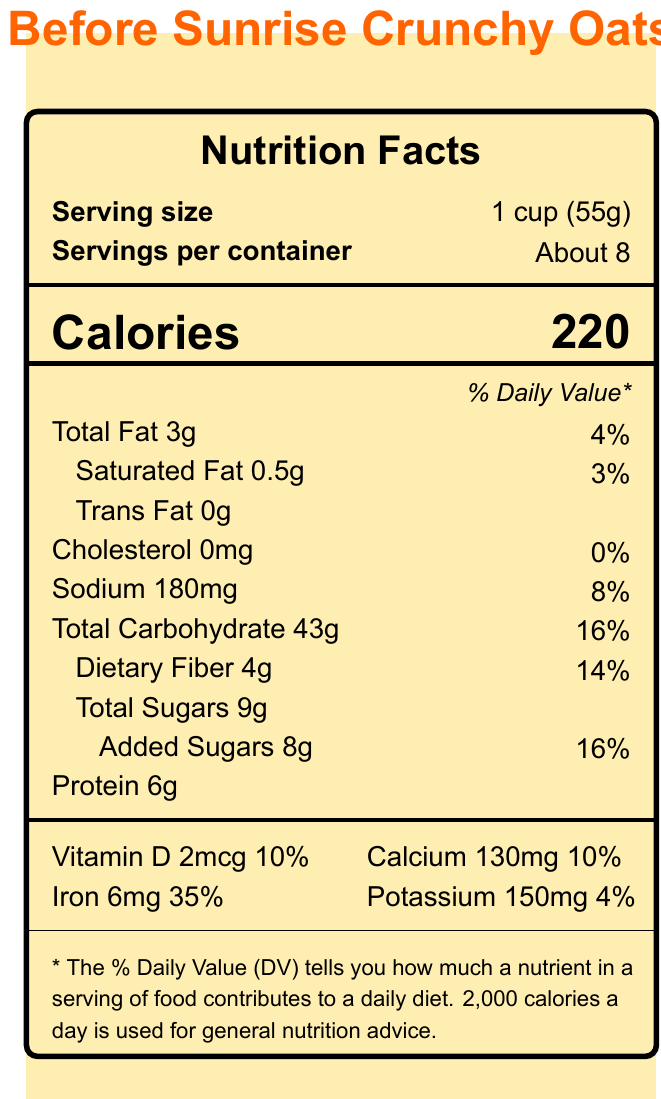what is the serving size? The serving size is clearly labeled as "1 cup (55g)" near the top of the Nutrition Facts section.
Answer: 1 cup (55g) how many calories are in one serving? The document lists "Calories" as 220 right beneath the serving size information.
Answer: 220 what is the percentage of Daily Value for Total Fat? The percentage of Daily Value for Total Fat is listed as 4% next to the amount of 3g.
Answer: 4% what is the amount of Dietary Fiber per serving? The amount of Dietary Fiber is listed as 4g.
Answer: 4g what vitamins and minerals are included in this cereal? The vitamins and minerals are listed towards the bottom of the Nutrition Facts as Vitamin D, Calcium, Iron, and Potassium.
Answer: Vitamin D, Calcium, Iron, Potassium which ingredient is listed first? A. Sugar B. Whole grain oats C. Corn syrup Whole grain oats is the first ingredient listed.
Answer: B what is the amount of sodium in the cereal? A. 180mg B. 150mg C. 130mg D. 0mg The amount of sodium is listed as 180mg.
Answer: A Is this cereal high in iron? (Yes/No) The Daily Value percentage for iron is 35%, which is relatively high.
Answer: Yes summarize the main information found in the document. The document showcases comprehensive nutritional information of the cereal "Before Sunrise Crunchy Oats" such as calorie content and nutrient percentages. It further includes ingredient and allergen details, fun facts about the "Before" trilogy, and a movie quote.
Answer: The document provides Nutrition Facts for "Before Sunrise Crunchy Oats" cereal, including serving size, calories, amounts of fats, cholesterol, sodium, carbohydrates, sugars, protein, and vitamins and minerals. It also lists ingredients and allergen information. Additionally, it features filmmaker trivia about Richard Linklater's "Before" trilogy and a quote from the movie. how is the cereal allergen information indicated? Allergens are indicated in a distinct statement that mentions the presence of wheat ingredients and potential traces of nuts.
Answer: "Contains wheat ingredients. May contain traces of nuts." how does the document highlight the connection to the "Before" trilogy? (Choose all that apply) 
1. Nutrition facts 
2. Movie quote 
3. Filmmaker trivia 
4. Ingredients The document includes a movie quote from "Before Sunrise" and filmmaker trivia about the "Before" trilogy, connecting the cereal to the films.
Answer: 2 and 3 what is the movie quote included in the document? This quote from Jesse in the movie "Before Sunrise" is noted in the document, providing a thematic link to the cereal.
Answer: "I believe if there's any kind of God it wouldn't be in any of us, not you or me but just this little space in between." - Jesse, Before Sunrise How long did the 'Before' trilogy span? According to the filmmaker trivia, the 'Before' trilogy spans 18 years.
Answer: 18 years what is the amount of added sugars per serving? The amount of added sugars in the cereal is 8g, as listed under the Total Sugars information.
Answer: 8g what flavor ingredients are used in the cereal? The document lists general ingredients but does not specify flavoring agents or specific flavor profiles beyond general components like Whole grain oats, Sugar, etc.
Answer: Cannot be determined 